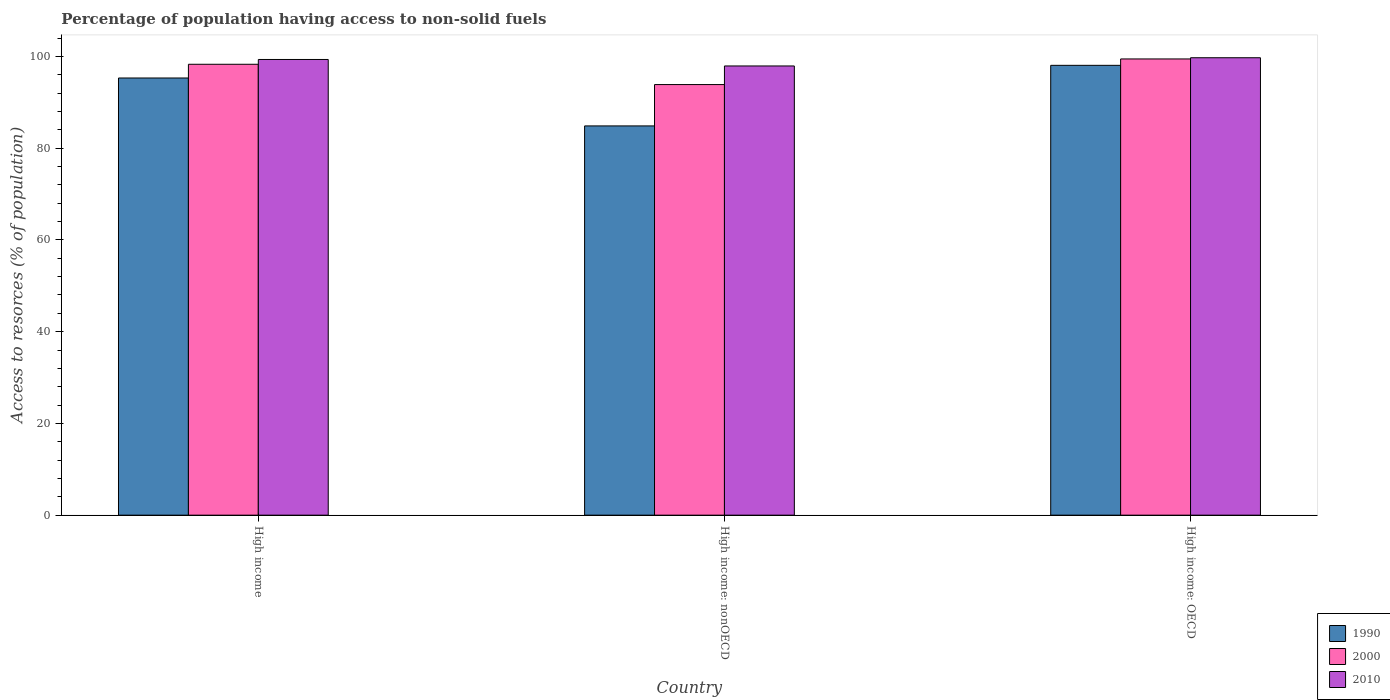How many groups of bars are there?
Keep it short and to the point. 3. Are the number of bars per tick equal to the number of legend labels?
Make the answer very short. Yes. Are the number of bars on each tick of the X-axis equal?
Make the answer very short. Yes. How many bars are there on the 1st tick from the right?
Your answer should be compact. 3. What is the label of the 2nd group of bars from the left?
Ensure brevity in your answer.  High income: nonOECD. What is the percentage of population having access to non-solid fuels in 2000 in High income?
Your response must be concise. 98.3. Across all countries, what is the maximum percentage of population having access to non-solid fuels in 2010?
Offer a terse response. 99.72. Across all countries, what is the minimum percentage of population having access to non-solid fuels in 2010?
Your answer should be very brief. 97.93. In which country was the percentage of population having access to non-solid fuels in 1990 maximum?
Offer a terse response. High income: OECD. In which country was the percentage of population having access to non-solid fuels in 2010 minimum?
Provide a short and direct response. High income: nonOECD. What is the total percentage of population having access to non-solid fuels in 2000 in the graph?
Make the answer very short. 291.63. What is the difference between the percentage of population having access to non-solid fuels in 1990 in High income: OECD and that in High income: nonOECD?
Give a very brief answer. 13.21. What is the difference between the percentage of population having access to non-solid fuels in 1990 in High income and the percentage of population having access to non-solid fuels in 2010 in High income: OECD?
Your answer should be compact. -4.41. What is the average percentage of population having access to non-solid fuels in 1990 per country?
Ensure brevity in your answer.  92.74. What is the difference between the percentage of population having access to non-solid fuels of/in 2000 and percentage of population having access to non-solid fuels of/in 2010 in High income: nonOECD?
Ensure brevity in your answer.  -4.06. In how many countries, is the percentage of population having access to non-solid fuels in 1990 greater than 92 %?
Make the answer very short. 2. What is the ratio of the percentage of population having access to non-solid fuels in 2010 in High income to that in High income: OECD?
Provide a short and direct response. 1. What is the difference between the highest and the second highest percentage of population having access to non-solid fuels in 2010?
Provide a short and direct response. 1.41. What is the difference between the highest and the lowest percentage of population having access to non-solid fuels in 2010?
Your answer should be very brief. 1.79. Is the sum of the percentage of population having access to non-solid fuels in 2000 in High income: OECD and High income: nonOECD greater than the maximum percentage of population having access to non-solid fuels in 2010 across all countries?
Keep it short and to the point. Yes. What does the 3rd bar from the left in High income: OECD represents?
Make the answer very short. 2010. What does the 1st bar from the right in High income represents?
Keep it short and to the point. 2010. Is it the case that in every country, the sum of the percentage of population having access to non-solid fuels in 1990 and percentage of population having access to non-solid fuels in 2000 is greater than the percentage of population having access to non-solid fuels in 2010?
Your answer should be very brief. Yes. Are all the bars in the graph horizontal?
Ensure brevity in your answer.  No. Does the graph contain any zero values?
Provide a succinct answer. No. Does the graph contain grids?
Provide a succinct answer. No. Where does the legend appear in the graph?
Offer a terse response. Bottom right. How many legend labels are there?
Provide a succinct answer. 3. What is the title of the graph?
Provide a succinct answer. Percentage of population having access to non-solid fuels. Does "1987" appear as one of the legend labels in the graph?
Make the answer very short. No. What is the label or title of the Y-axis?
Offer a terse response. Access to resorces (% of population). What is the Access to resorces (% of population) of 1990 in High income?
Provide a succinct answer. 95.31. What is the Access to resorces (% of population) in 2000 in High income?
Keep it short and to the point. 98.3. What is the Access to resorces (% of population) of 2010 in High income?
Provide a succinct answer. 99.34. What is the Access to resorces (% of population) in 1990 in High income: nonOECD?
Your response must be concise. 84.86. What is the Access to resorces (% of population) in 2000 in High income: nonOECD?
Your response must be concise. 93.87. What is the Access to resorces (% of population) in 2010 in High income: nonOECD?
Make the answer very short. 97.93. What is the Access to resorces (% of population) in 1990 in High income: OECD?
Offer a very short reply. 98.07. What is the Access to resorces (% of population) in 2000 in High income: OECD?
Your answer should be very brief. 99.46. What is the Access to resorces (% of population) of 2010 in High income: OECD?
Provide a short and direct response. 99.72. Across all countries, what is the maximum Access to resorces (% of population) of 1990?
Give a very brief answer. 98.07. Across all countries, what is the maximum Access to resorces (% of population) of 2000?
Ensure brevity in your answer.  99.46. Across all countries, what is the maximum Access to resorces (% of population) of 2010?
Keep it short and to the point. 99.72. Across all countries, what is the minimum Access to resorces (% of population) in 1990?
Provide a short and direct response. 84.86. Across all countries, what is the minimum Access to resorces (% of population) of 2000?
Provide a succinct answer. 93.87. Across all countries, what is the minimum Access to resorces (% of population) of 2010?
Your response must be concise. 97.93. What is the total Access to resorces (% of population) in 1990 in the graph?
Your answer should be very brief. 278.23. What is the total Access to resorces (% of population) in 2000 in the graph?
Ensure brevity in your answer.  291.63. What is the total Access to resorces (% of population) in 2010 in the graph?
Offer a very short reply. 296.99. What is the difference between the Access to resorces (% of population) of 1990 in High income and that in High income: nonOECD?
Provide a short and direct response. 10.45. What is the difference between the Access to resorces (% of population) of 2000 in High income and that in High income: nonOECD?
Provide a succinct answer. 4.43. What is the difference between the Access to resorces (% of population) in 2010 in High income and that in High income: nonOECD?
Your answer should be very brief. 1.41. What is the difference between the Access to resorces (% of population) in 1990 in High income and that in High income: OECD?
Provide a succinct answer. -2.76. What is the difference between the Access to resorces (% of population) in 2000 in High income and that in High income: OECD?
Provide a succinct answer. -1.16. What is the difference between the Access to resorces (% of population) of 2010 in High income and that in High income: OECD?
Provide a short and direct response. -0.38. What is the difference between the Access to resorces (% of population) of 1990 in High income: nonOECD and that in High income: OECD?
Ensure brevity in your answer.  -13.21. What is the difference between the Access to resorces (% of population) of 2000 in High income: nonOECD and that in High income: OECD?
Offer a very short reply. -5.59. What is the difference between the Access to resorces (% of population) of 2010 in High income: nonOECD and that in High income: OECD?
Offer a terse response. -1.79. What is the difference between the Access to resorces (% of population) in 1990 in High income and the Access to resorces (% of population) in 2000 in High income: nonOECD?
Your response must be concise. 1.44. What is the difference between the Access to resorces (% of population) in 1990 in High income and the Access to resorces (% of population) in 2010 in High income: nonOECD?
Offer a very short reply. -2.62. What is the difference between the Access to resorces (% of population) of 2000 in High income and the Access to resorces (% of population) of 2010 in High income: nonOECD?
Ensure brevity in your answer.  0.37. What is the difference between the Access to resorces (% of population) of 1990 in High income and the Access to resorces (% of population) of 2000 in High income: OECD?
Provide a short and direct response. -4.15. What is the difference between the Access to resorces (% of population) in 1990 in High income and the Access to resorces (% of population) in 2010 in High income: OECD?
Your response must be concise. -4.41. What is the difference between the Access to resorces (% of population) of 2000 in High income and the Access to resorces (% of population) of 2010 in High income: OECD?
Make the answer very short. -1.42. What is the difference between the Access to resorces (% of population) in 1990 in High income: nonOECD and the Access to resorces (% of population) in 2000 in High income: OECD?
Make the answer very short. -14.6. What is the difference between the Access to resorces (% of population) of 1990 in High income: nonOECD and the Access to resorces (% of population) of 2010 in High income: OECD?
Give a very brief answer. -14.86. What is the difference between the Access to resorces (% of population) of 2000 in High income: nonOECD and the Access to resorces (% of population) of 2010 in High income: OECD?
Your answer should be very brief. -5.85. What is the average Access to resorces (% of population) of 1990 per country?
Provide a succinct answer. 92.74. What is the average Access to resorces (% of population) of 2000 per country?
Your response must be concise. 97.21. What is the average Access to resorces (% of population) of 2010 per country?
Provide a succinct answer. 99. What is the difference between the Access to resorces (% of population) in 1990 and Access to resorces (% of population) in 2000 in High income?
Make the answer very short. -2.99. What is the difference between the Access to resorces (% of population) in 1990 and Access to resorces (% of population) in 2010 in High income?
Provide a short and direct response. -4.04. What is the difference between the Access to resorces (% of population) of 2000 and Access to resorces (% of population) of 2010 in High income?
Keep it short and to the point. -1.04. What is the difference between the Access to resorces (% of population) of 1990 and Access to resorces (% of population) of 2000 in High income: nonOECD?
Offer a very short reply. -9.01. What is the difference between the Access to resorces (% of population) of 1990 and Access to resorces (% of population) of 2010 in High income: nonOECD?
Give a very brief answer. -13.07. What is the difference between the Access to resorces (% of population) in 2000 and Access to resorces (% of population) in 2010 in High income: nonOECD?
Your response must be concise. -4.06. What is the difference between the Access to resorces (% of population) in 1990 and Access to resorces (% of population) in 2000 in High income: OECD?
Your answer should be compact. -1.39. What is the difference between the Access to resorces (% of population) of 1990 and Access to resorces (% of population) of 2010 in High income: OECD?
Your answer should be compact. -1.65. What is the difference between the Access to resorces (% of population) in 2000 and Access to resorces (% of population) in 2010 in High income: OECD?
Your response must be concise. -0.26. What is the ratio of the Access to resorces (% of population) in 1990 in High income to that in High income: nonOECD?
Provide a succinct answer. 1.12. What is the ratio of the Access to resorces (% of population) in 2000 in High income to that in High income: nonOECD?
Offer a very short reply. 1.05. What is the ratio of the Access to resorces (% of population) in 2010 in High income to that in High income: nonOECD?
Provide a succinct answer. 1.01. What is the ratio of the Access to resorces (% of population) of 1990 in High income to that in High income: OECD?
Make the answer very short. 0.97. What is the ratio of the Access to resorces (% of population) of 2000 in High income to that in High income: OECD?
Offer a terse response. 0.99. What is the ratio of the Access to resorces (% of population) of 1990 in High income: nonOECD to that in High income: OECD?
Provide a succinct answer. 0.87. What is the ratio of the Access to resorces (% of population) in 2000 in High income: nonOECD to that in High income: OECD?
Give a very brief answer. 0.94. What is the ratio of the Access to resorces (% of population) of 2010 in High income: nonOECD to that in High income: OECD?
Keep it short and to the point. 0.98. What is the difference between the highest and the second highest Access to resorces (% of population) in 1990?
Your answer should be compact. 2.76. What is the difference between the highest and the second highest Access to resorces (% of population) of 2000?
Give a very brief answer. 1.16. What is the difference between the highest and the second highest Access to resorces (% of population) of 2010?
Give a very brief answer. 0.38. What is the difference between the highest and the lowest Access to resorces (% of population) of 1990?
Offer a terse response. 13.21. What is the difference between the highest and the lowest Access to resorces (% of population) in 2000?
Your answer should be very brief. 5.59. What is the difference between the highest and the lowest Access to resorces (% of population) of 2010?
Make the answer very short. 1.79. 